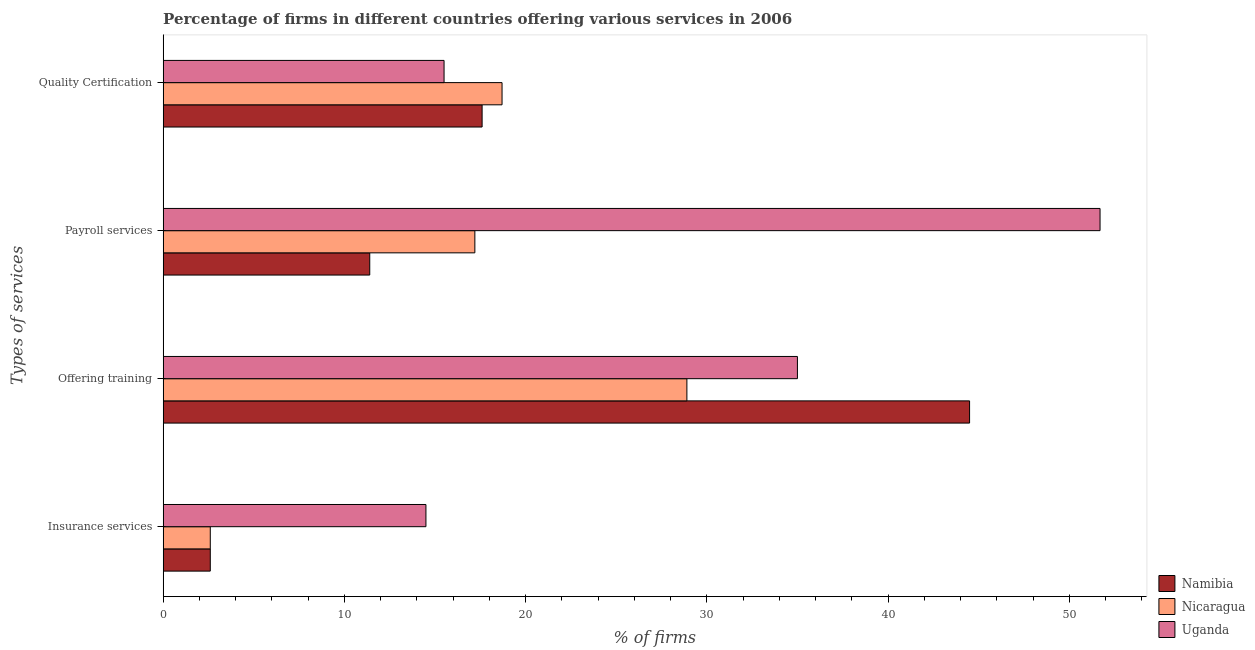How many bars are there on the 1st tick from the bottom?
Your answer should be very brief. 3. What is the label of the 3rd group of bars from the top?
Your response must be concise. Offering training. Across all countries, what is the maximum percentage of firms offering training?
Keep it short and to the point. 44.5. Across all countries, what is the minimum percentage of firms offering training?
Your answer should be very brief. 28.9. In which country was the percentage of firms offering training maximum?
Keep it short and to the point. Namibia. In which country was the percentage of firms offering quality certification minimum?
Keep it short and to the point. Uganda. What is the difference between the percentage of firms offering training in Namibia and that in Uganda?
Give a very brief answer. 9.5. What is the difference between the percentage of firms offering quality certification in Nicaragua and the percentage of firms offering insurance services in Namibia?
Provide a short and direct response. 16.1. What is the average percentage of firms offering payroll services per country?
Make the answer very short. 26.77. What is the difference between the percentage of firms offering training and percentage of firms offering payroll services in Namibia?
Ensure brevity in your answer.  33.1. What is the ratio of the percentage of firms offering payroll services in Namibia to that in Nicaragua?
Your answer should be compact. 0.66. What is the difference between the highest and the second highest percentage of firms offering insurance services?
Give a very brief answer. 11.9. What is the difference between the highest and the lowest percentage of firms offering quality certification?
Provide a short and direct response. 3.2. What does the 3rd bar from the top in Offering training represents?
Offer a very short reply. Namibia. What does the 1st bar from the bottom in Offering training represents?
Provide a short and direct response. Namibia. Is it the case that in every country, the sum of the percentage of firms offering insurance services and percentage of firms offering training is greater than the percentage of firms offering payroll services?
Make the answer very short. No. What is the difference between two consecutive major ticks on the X-axis?
Your answer should be compact. 10. Does the graph contain any zero values?
Give a very brief answer. No. Does the graph contain grids?
Offer a terse response. No. Where does the legend appear in the graph?
Your answer should be very brief. Bottom right. What is the title of the graph?
Keep it short and to the point. Percentage of firms in different countries offering various services in 2006. What is the label or title of the X-axis?
Make the answer very short. % of firms. What is the label or title of the Y-axis?
Make the answer very short. Types of services. What is the % of firms in Uganda in Insurance services?
Your answer should be very brief. 14.5. What is the % of firms in Namibia in Offering training?
Your response must be concise. 44.5. What is the % of firms of Nicaragua in Offering training?
Your response must be concise. 28.9. What is the % of firms of Uganda in Offering training?
Offer a very short reply. 35. What is the % of firms in Namibia in Payroll services?
Your answer should be very brief. 11.4. What is the % of firms in Nicaragua in Payroll services?
Offer a very short reply. 17.2. What is the % of firms of Uganda in Payroll services?
Provide a short and direct response. 51.7. What is the % of firms of Namibia in Quality Certification?
Your response must be concise. 17.6. What is the % of firms of Uganda in Quality Certification?
Provide a succinct answer. 15.5. Across all Types of services, what is the maximum % of firms of Namibia?
Your answer should be very brief. 44.5. Across all Types of services, what is the maximum % of firms of Nicaragua?
Provide a short and direct response. 28.9. Across all Types of services, what is the maximum % of firms of Uganda?
Offer a very short reply. 51.7. Across all Types of services, what is the minimum % of firms of Namibia?
Offer a very short reply. 2.6. Across all Types of services, what is the minimum % of firms in Nicaragua?
Make the answer very short. 2.6. What is the total % of firms of Namibia in the graph?
Provide a succinct answer. 76.1. What is the total % of firms of Nicaragua in the graph?
Your answer should be compact. 67.4. What is the total % of firms in Uganda in the graph?
Your response must be concise. 116.7. What is the difference between the % of firms of Namibia in Insurance services and that in Offering training?
Give a very brief answer. -41.9. What is the difference between the % of firms of Nicaragua in Insurance services and that in Offering training?
Make the answer very short. -26.3. What is the difference between the % of firms in Uganda in Insurance services and that in Offering training?
Make the answer very short. -20.5. What is the difference between the % of firms in Namibia in Insurance services and that in Payroll services?
Offer a terse response. -8.8. What is the difference between the % of firms in Nicaragua in Insurance services and that in Payroll services?
Keep it short and to the point. -14.6. What is the difference between the % of firms of Uganda in Insurance services and that in Payroll services?
Ensure brevity in your answer.  -37.2. What is the difference between the % of firms in Namibia in Insurance services and that in Quality Certification?
Offer a terse response. -15. What is the difference between the % of firms of Nicaragua in Insurance services and that in Quality Certification?
Ensure brevity in your answer.  -16.1. What is the difference between the % of firms of Uganda in Insurance services and that in Quality Certification?
Give a very brief answer. -1. What is the difference between the % of firms of Namibia in Offering training and that in Payroll services?
Offer a very short reply. 33.1. What is the difference between the % of firms of Uganda in Offering training and that in Payroll services?
Ensure brevity in your answer.  -16.7. What is the difference between the % of firms of Namibia in Offering training and that in Quality Certification?
Ensure brevity in your answer.  26.9. What is the difference between the % of firms in Uganda in Payroll services and that in Quality Certification?
Ensure brevity in your answer.  36.2. What is the difference between the % of firms in Namibia in Insurance services and the % of firms in Nicaragua in Offering training?
Make the answer very short. -26.3. What is the difference between the % of firms of Namibia in Insurance services and the % of firms of Uganda in Offering training?
Ensure brevity in your answer.  -32.4. What is the difference between the % of firms in Nicaragua in Insurance services and the % of firms in Uganda in Offering training?
Provide a succinct answer. -32.4. What is the difference between the % of firms of Namibia in Insurance services and the % of firms of Nicaragua in Payroll services?
Offer a very short reply. -14.6. What is the difference between the % of firms of Namibia in Insurance services and the % of firms of Uganda in Payroll services?
Offer a terse response. -49.1. What is the difference between the % of firms of Nicaragua in Insurance services and the % of firms of Uganda in Payroll services?
Offer a terse response. -49.1. What is the difference between the % of firms of Namibia in Insurance services and the % of firms of Nicaragua in Quality Certification?
Make the answer very short. -16.1. What is the difference between the % of firms of Namibia in Offering training and the % of firms of Nicaragua in Payroll services?
Your answer should be very brief. 27.3. What is the difference between the % of firms of Namibia in Offering training and the % of firms of Uganda in Payroll services?
Your answer should be very brief. -7.2. What is the difference between the % of firms in Nicaragua in Offering training and the % of firms in Uganda in Payroll services?
Offer a very short reply. -22.8. What is the difference between the % of firms of Namibia in Offering training and the % of firms of Nicaragua in Quality Certification?
Provide a succinct answer. 25.8. What is the difference between the % of firms in Namibia in Payroll services and the % of firms in Nicaragua in Quality Certification?
Your response must be concise. -7.3. What is the difference between the % of firms of Nicaragua in Payroll services and the % of firms of Uganda in Quality Certification?
Offer a very short reply. 1.7. What is the average % of firms in Namibia per Types of services?
Provide a succinct answer. 19.02. What is the average % of firms of Nicaragua per Types of services?
Offer a terse response. 16.85. What is the average % of firms of Uganda per Types of services?
Your answer should be very brief. 29.18. What is the difference between the % of firms in Nicaragua and % of firms in Uganda in Insurance services?
Provide a succinct answer. -11.9. What is the difference between the % of firms of Namibia and % of firms of Uganda in Offering training?
Your answer should be compact. 9.5. What is the difference between the % of firms in Namibia and % of firms in Nicaragua in Payroll services?
Your answer should be very brief. -5.8. What is the difference between the % of firms in Namibia and % of firms in Uganda in Payroll services?
Make the answer very short. -40.3. What is the difference between the % of firms in Nicaragua and % of firms in Uganda in Payroll services?
Offer a terse response. -34.5. What is the ratio of the % of firms of Namibia in Insurance services to that in Offering training?
Your response must be concise. 0.06. What is the ratio of the % of firms of Nicaragua in Insurance services to that in Offering training?
Your answer should be compact. 0.09. What is the ratio of the % of firms in Uganda in Insurance services to that in Offering training?
Your answer should be compact. 0.41. What is the ratio of the % of firms in Namibia in Insurance services to that in Payroll services?
Your response must be concise. 0.23. What is the ratio of the % of firms of Nicaragua in Insurance services to that in Payroll services?
Your answer should be very brief. 0.15. What is the ratio of the % of firms of Uganda in Insurance services to that in Payroll services?
Ensure brevity in your answer.  0.28. What is the ratio of the % of firms in Namibia in Insurance services to that in Quality Certification?
Keep it short and to the point. 0.15. What is the ratio of the % of firms in Nicaragua in Insurance services to that in Quality Certification?
Offer a terse response. 0.14. What is the ratio of the % of firms of Uganda in Insurance services to that in Quality Certification?
Offer a very short reply. 0.94. What is the ratio of the % of firms of Namibia in Offering training to that in Payroll services?
Provide a short and direct response. 3.9. What is the ratio of the % of firms in Nicaragua in Offering training to that in Payroll services?
Offer a very short reply. 1.68. What is the ratio of the % of firms in Uganda in Offering training to that in Payroll services?
Give a very brief answer. 0.68. What is the ratio of the % of firms of Namibia in Offering training to that in Quality Certification?
Provide a short and direct response. 2.53. What is the ratio of the % of firms of Nicaragua in Offering training to that in Quality Certification?
Ensure brevity in your answer.  1.55. What is the ratio of the % of firms of Uganda in Offering training to that in Quality Certification?
Give a very brief answer. 2.26. What is the ratio of the % of firms of Namibia in Payroll services to that in Quality Certification?
Provide a short and direct response. 0.65. What is the ratio of the % of firms in Nicaragua in Payroll services to that in Quality Certification?
Give a very brief answer. 0.92. What is the ratio of the % of firms of Uganda in Payroll services to that in Quality Certification?
Keep it short and to the point. 3.34. What is the difference between the highest and the second highest % of firms of Namibia?
Your answer should be compact. 26.9. What is the difference between the highest and the second highest % of firms in Nicaragua?
Your response must be concise. 10.2. What is the difference between the highest and the lowest % of firms of Namibia?
Offer a very short reply. 41.9. What is the difference between the highest and the lowest % of firms of Nicaragua?
Your response must be concise. 26.3. What is the difference between the highest and the lowest % of firms of Uganda?
Provide a short and direct response. 37.2. 